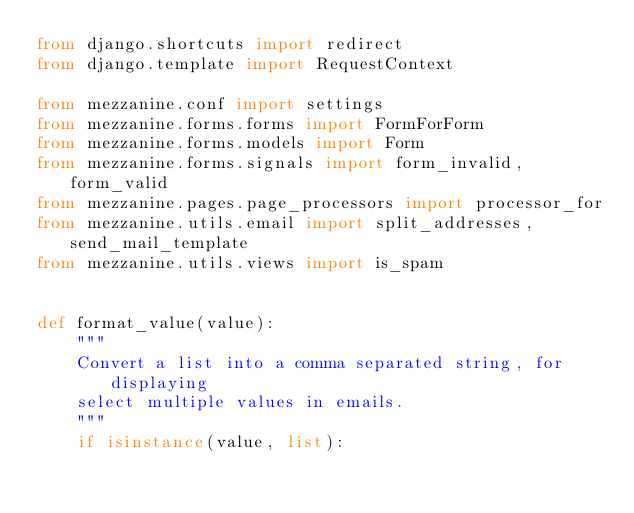<code> <loc_0><loc_0><loc_500><loc_500><_Python_>from django.shortcuts import redirect
from django.template import RequestContext

from mezzanine.conf import settings
from mezzanine.forms.forms import FormForForm
from mezzanine.forms.models import Form
from mezzanine.forms.signals import form_invalid, form_valid
from mezzanine.pages.page_processors import processor_for
from mezzanine.utils.email import split_addresses, send_mail_template
from mezzanine.utils.views import is_spam


def format_value(value):
    """
    Convert a list into a comma separated string, for displaying
    select multiple values in emails.
    """
    if isinstance(value, list):</code> 